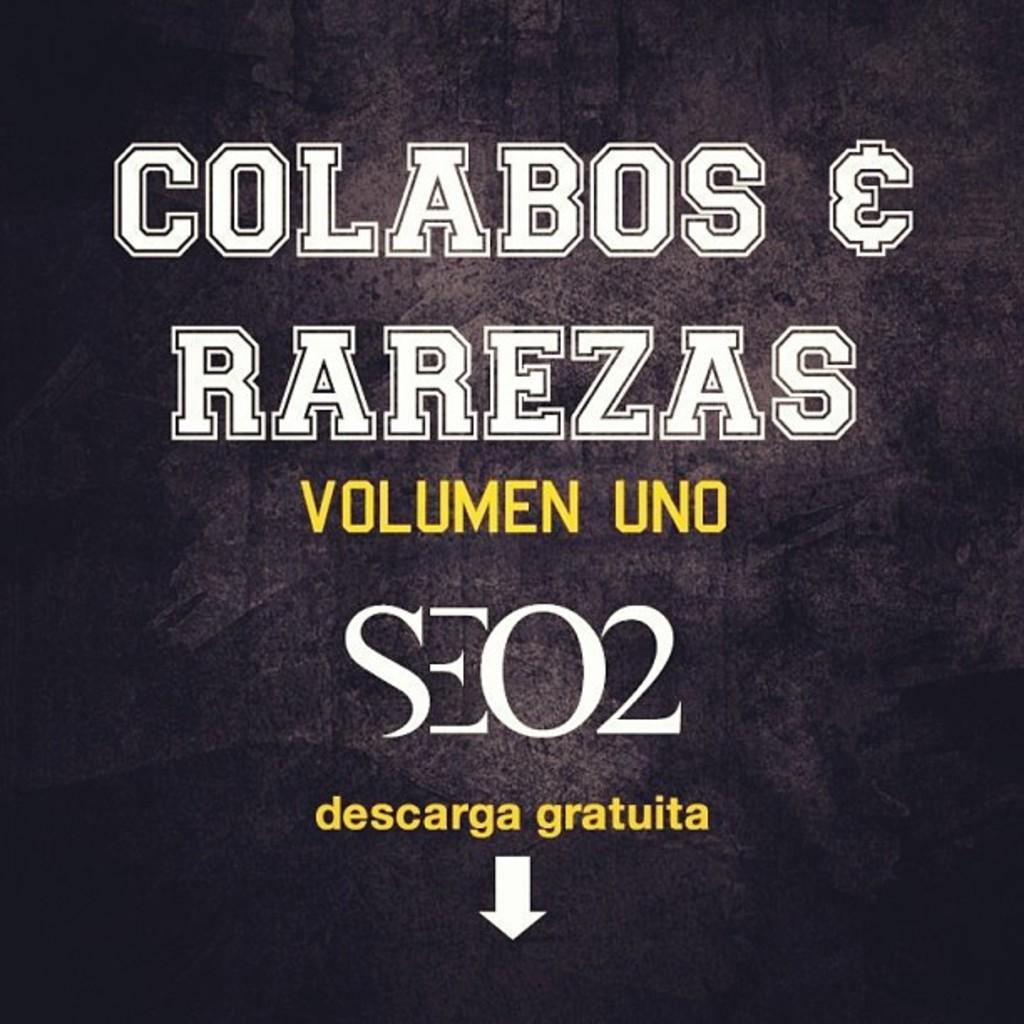What yellow words are just above the arrow?
Give a very brief answer. Descarga gratuita. What is the top left letter?
Your response must be concise. C. 